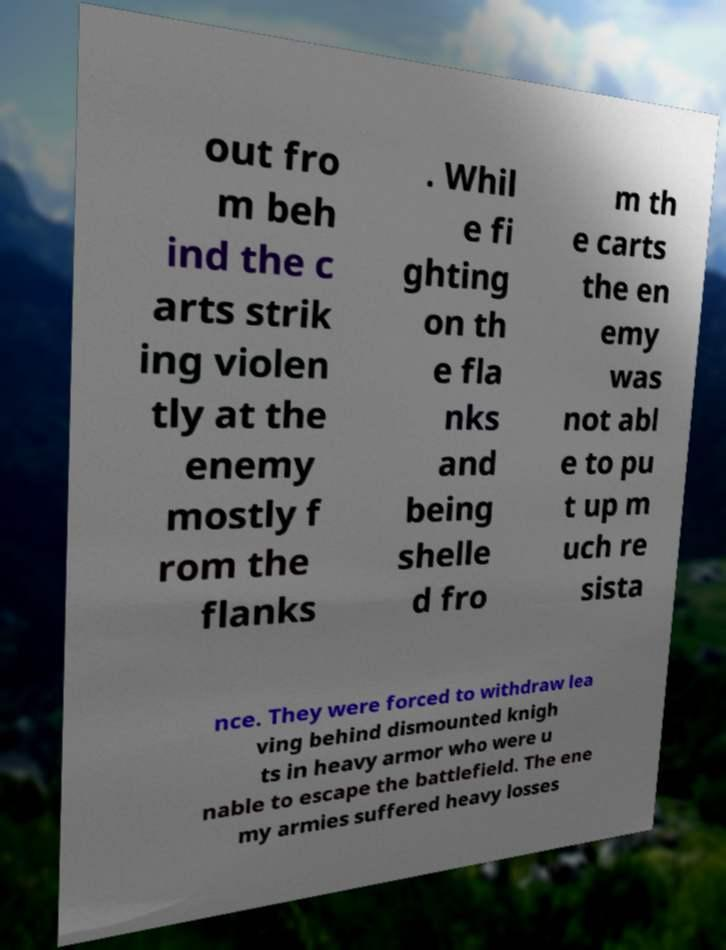Please identify and transcribe the text found in this image. out fro m beh ind the c arts strik ing violen tly at the enemy mostly f rom the flanks . Whil e fi ghting on th e fla nks and being shelle d fro m th e carts the en emy was not abl e to pu t up m uch re sista nce. They were forced to withdraw lea ving behind dismounted knigh ts in heavy armor who were u nable to escape the battlefield. The ene my armies suffered heavy losses 